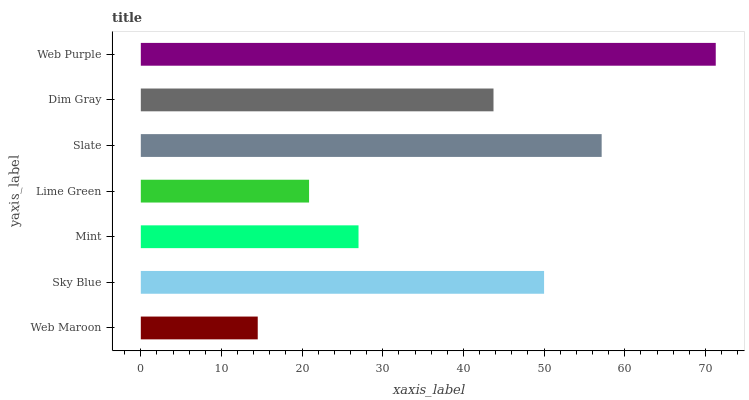Is Web Maroon the minimum?
Answer yes or no. Yes. Is Web Purple the maximum?
Answer yes or no. Yes. Is Sky Blue the minimum?
Answer yes or no. No. Is Sky Blue the maximum?
Answer yes or no. No. Is Sky Blue greater than Web Maroon?
Answer yes or no. Yes. Is Web Maroon less than Sky Blue?
Answer yes or no. Yes. Is Web Maroon greater than Sky Blue?
Answer yes or no. No. Is Sky Blue less than Web Maroon?
Answer yes or no. No. Is Dim Gray the high median?
Answer yes or no. Yes. Is Dim Gray the low median?
Answer yes or no. Yes. Is Web Maroon the high median?
Answer yes or no. No. Is Sky Blue the low median?
Answer yes or no. No. 